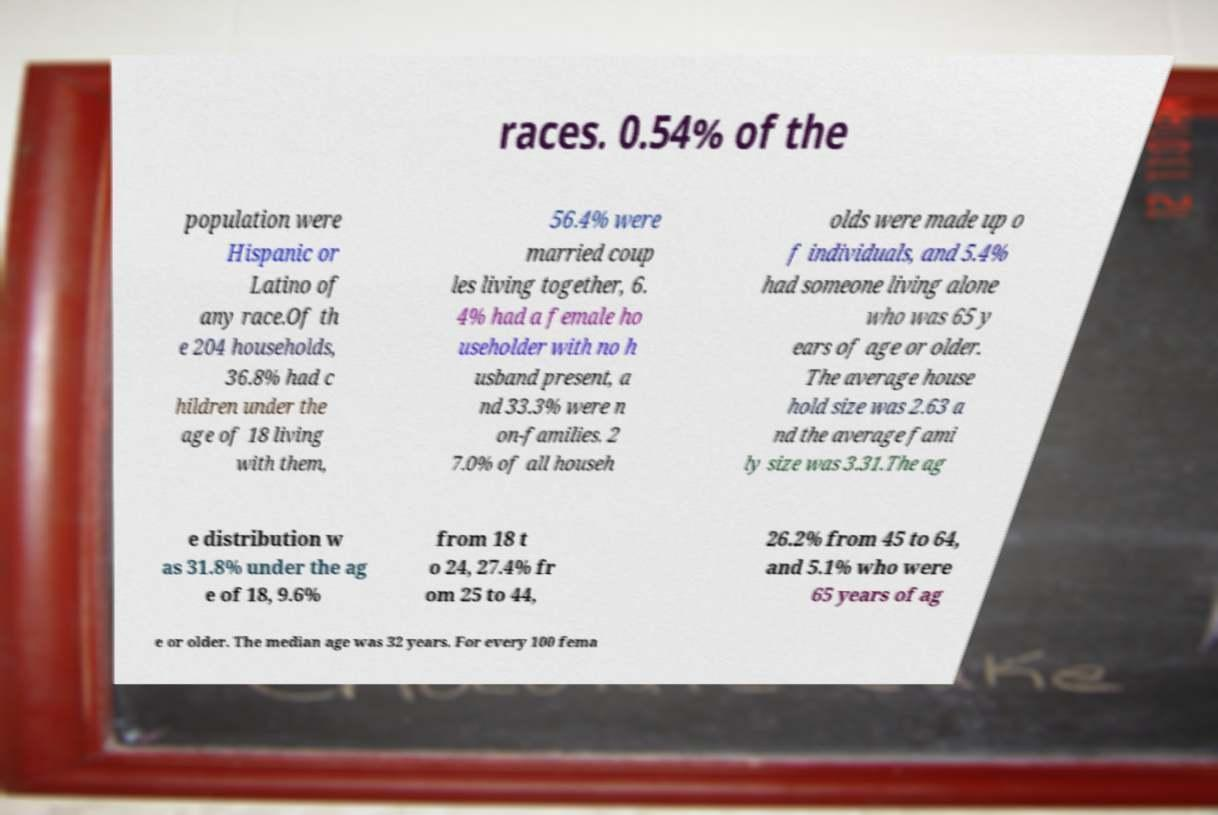What messages or text are displayed in this image? I need them in a readable, typed format. races. 0.54% of the population were Hispanic or Latino of any race.Of th e 204 households, 36.8% had c hildren under the age of 18 living with them, 56.4% were married coup les living together, 6. 4% had a female ho useholder with no h usband present, a nd 33.3% were n on-families. 2 7.0% of all househ olds were made up o f individuals, and 5.4% had someone living alone who was 65 y ears of age or older. The average house hold size was 2.63 a nd the average fami ly size was 3.31.The ag e distribution w as 31.8% under the ag e of 18, 9.6% from 18 t o 24, 27.4% fr om 25 to 44, 26.2% from 45 to 64, and 5.1% who were 65 years of ag e or older. The median age was 32 years. For every 100 fema 